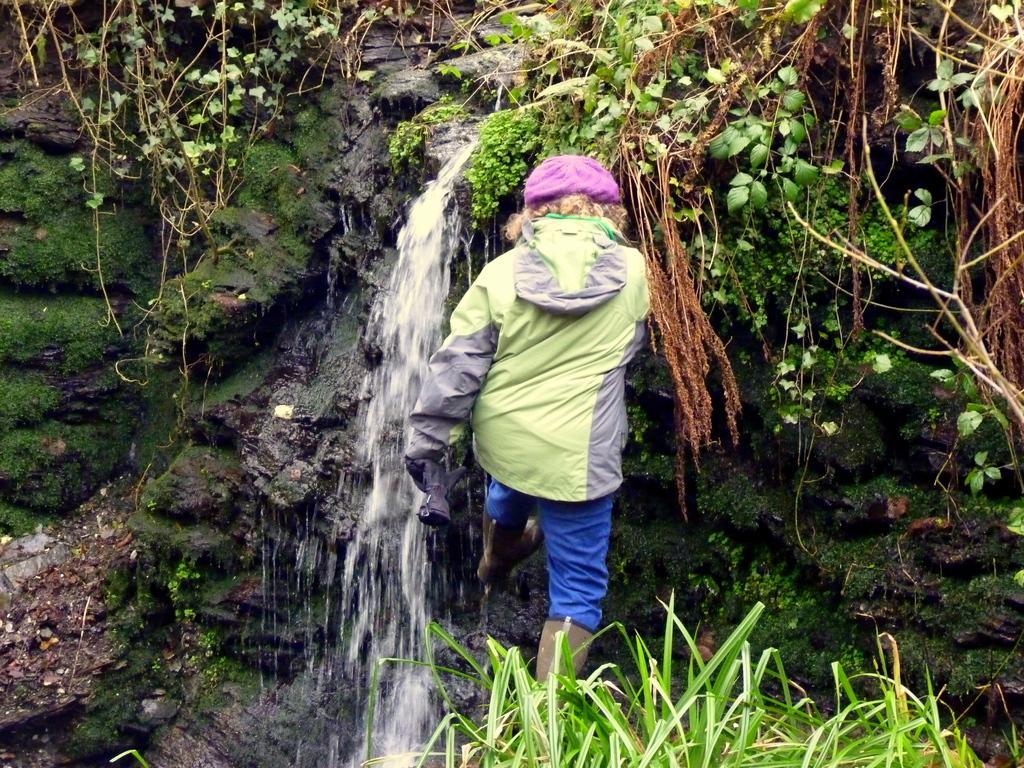Please provide a concise description of this image. In the picture we can see a person wearing green and ash color jacket, blue color pant, pink color cap standing, there is plant and in the background of the picture we can see waterfall, stone and there are some plants. 